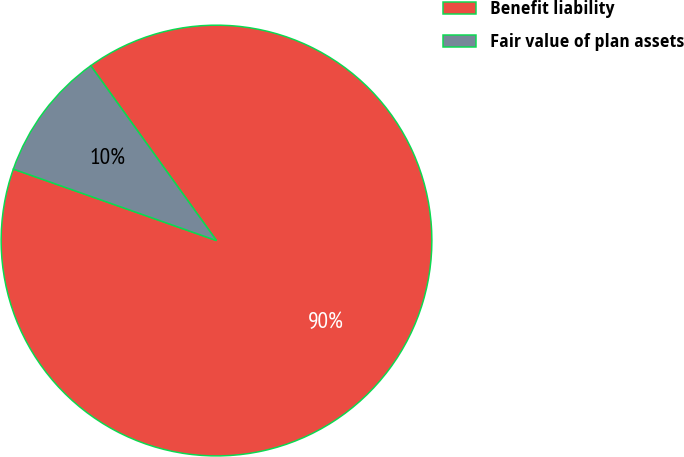Convert chart to OTSL. <chart><loc_0><loc_0><loc_500><loc_500><pie_chart><fcel>Benefit liability<fcel>Fair value of plan assets<nl><fcel>90.31%<fcel>9.69%<nl></chart> 